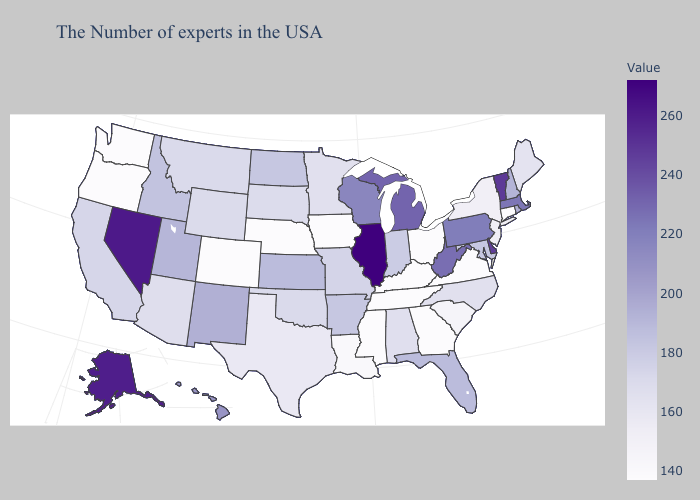Does Indiana have a lower value than Virginia?
Short answer required. No. Which states have the highest value in the USA?
Quick response, please. Illinois. Among the states that border Kansas , does Nebraska have the highest value?
Write a very short answer. No. Does the map have missing data?
Answer briefly. No. Which states have the highest value in the USA?
Give a very brief answer. Illinois. 